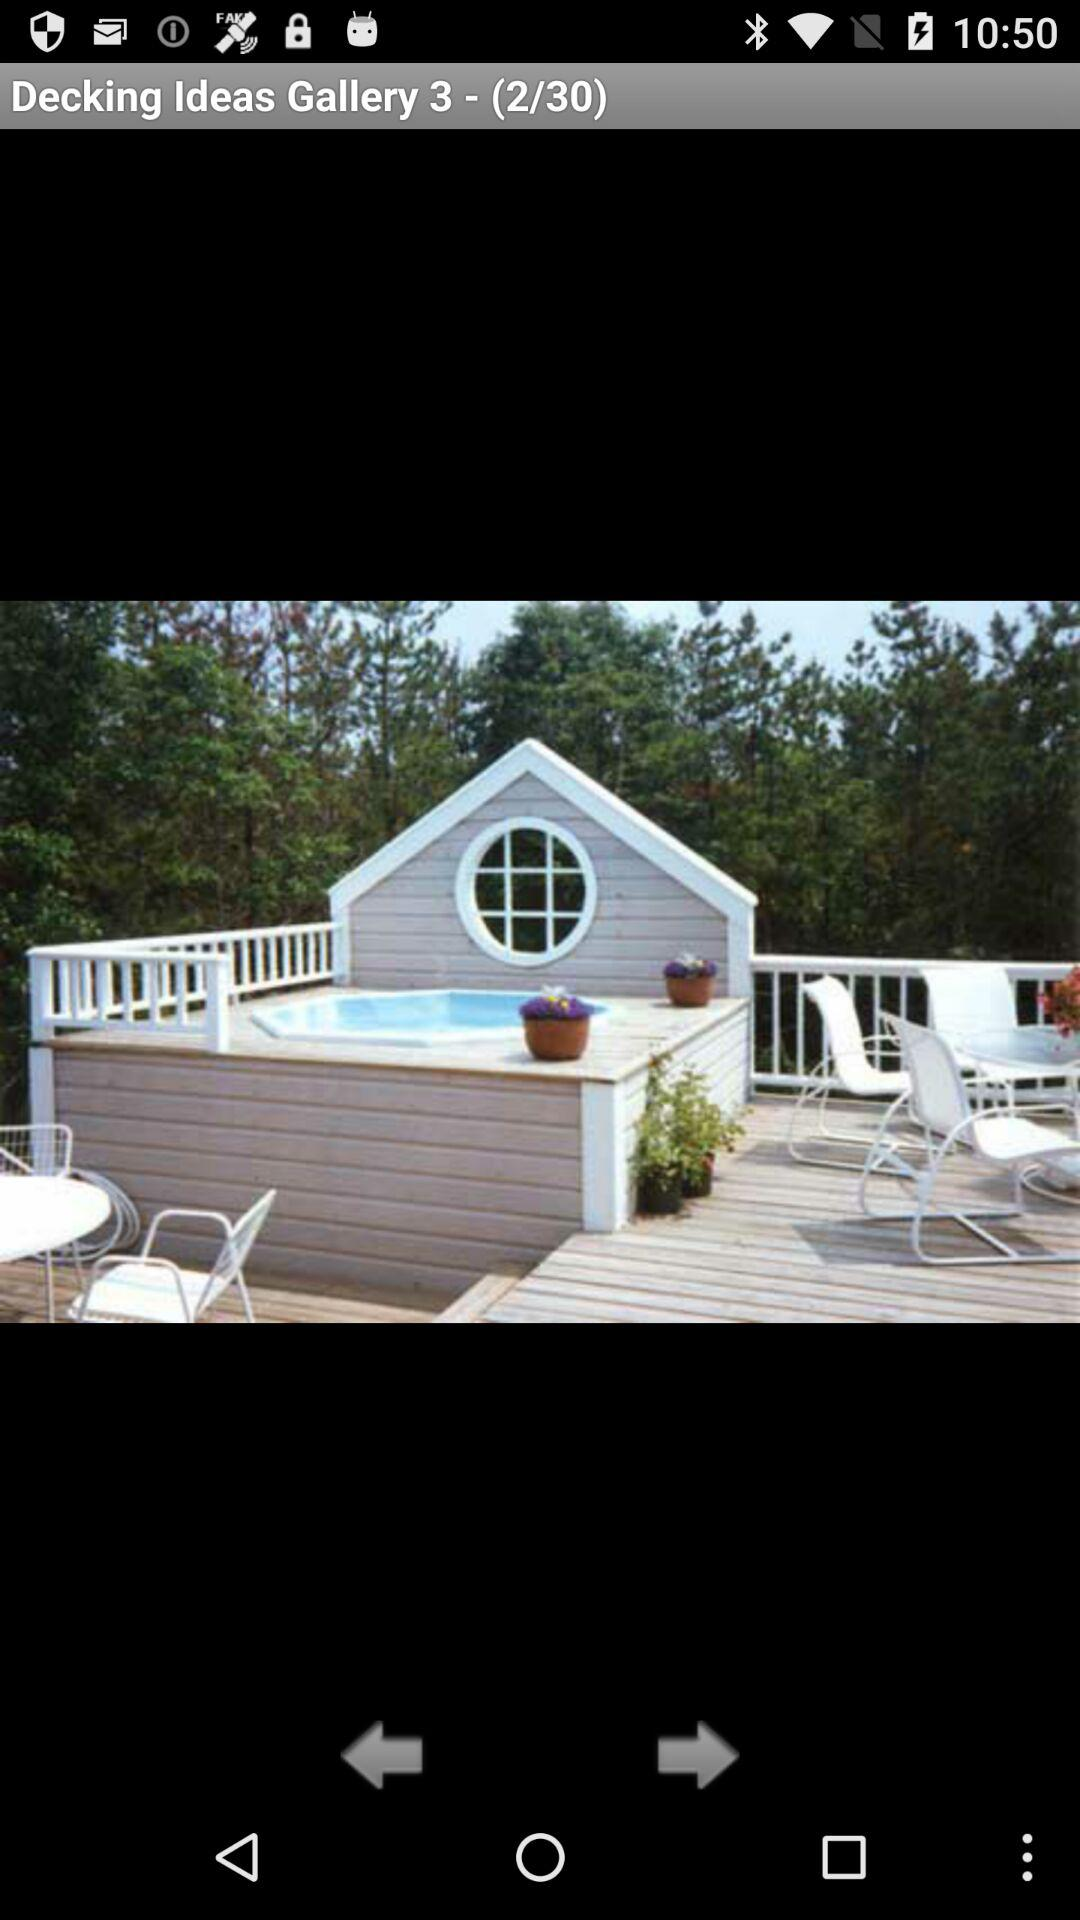What is the total number of photos available in the gallery? The total number of photos available in the gallery is 30. 